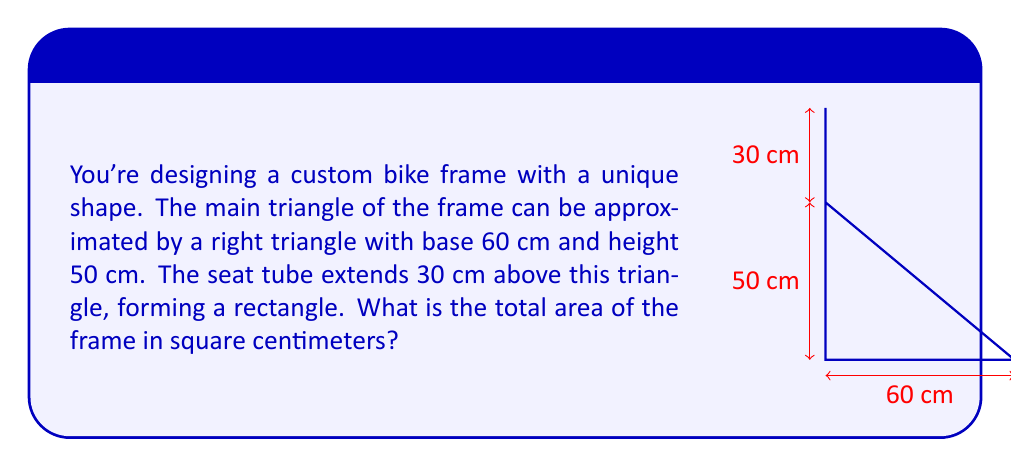Can you solve this math problem? Let's break this down step-by-step:

1) First, calculate the area of the triangle:
   Area of triangle = $\frac{1}{2} \times base \times height$
   $$ A_{triangle} = \frac{1}{2} \times 60 \times 50 = 1500 \text{ cm}^2 $$

2) Next, calculate the area of the rectangle:
   Area of rectangle = width $\times$ height
   The width is the same as the height of the triangle (50 cm).
   $$ A_{rectangle} = 50 \times 30 = 1500 \text{ cm}^2 $$

3) The total area is the sum of these two areas:
   $$ A_{total} = A_{triangle} + A_{rectangle} = 1500 + 1500 = 3000 \text{ cm}^2 $$

Therefore, the total area of the frame is 3000 square centimeters.
Answer: 3000 cm² 